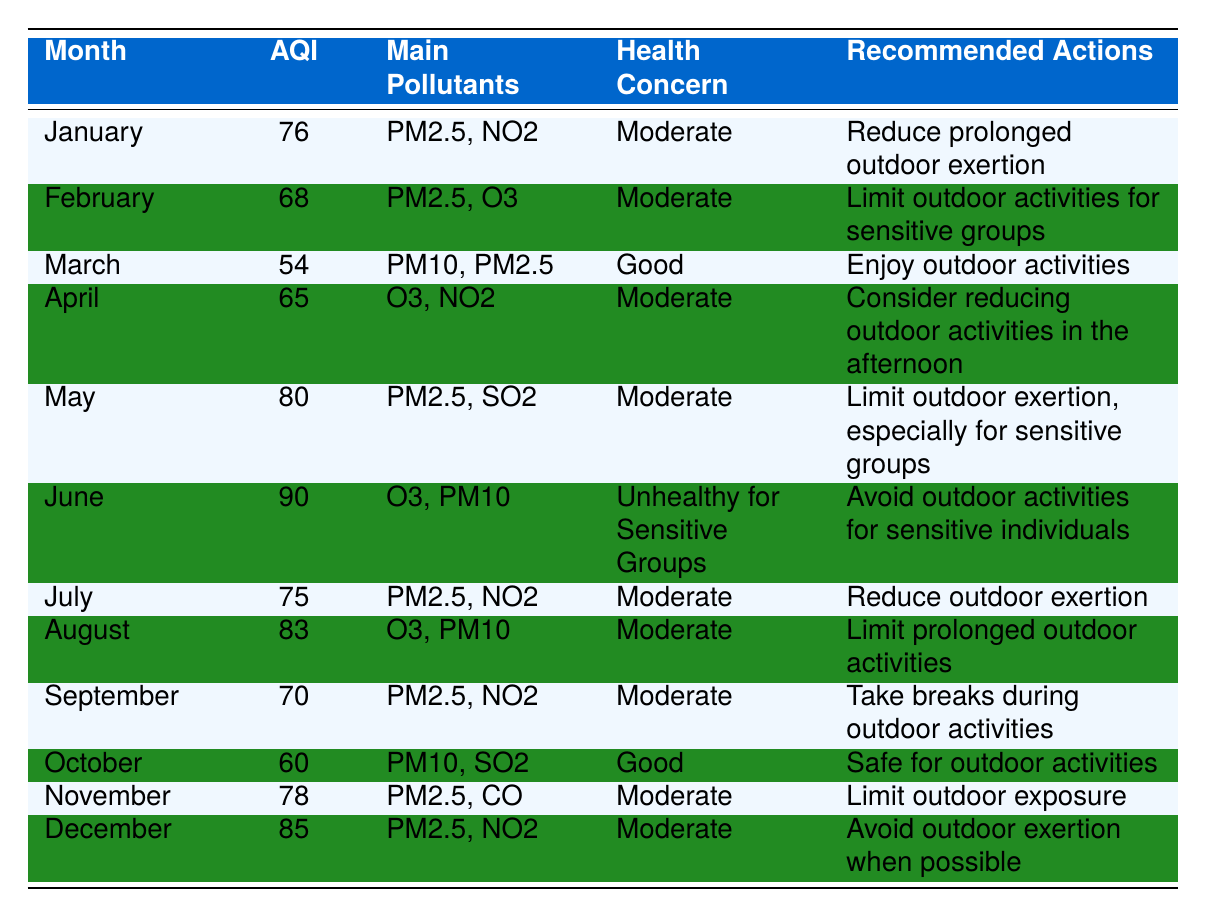What is the air quality index (AQI) for March? According to the table, the AQI listed for March is 54.
Answer: 54 Which month had the highest AQI reading in 2023? The table shows that June had the highest AQI reading of 90.
Answer: June Were there any months where the AQI was classified as Good? The table indicates that both March and October were classified as having a Good AQI.
Answer: Yes What are the main pollutants for the month of August? The table specifies that the main pollutants for August are O3 and PM10.
Answer: O3, PM10 How many months had an AQI above 75? By reviewing the AQI values in the table, only June (90), May (80), and December (85) exceed 75, resulting in a total of three months.
Answer: 3 What is the recommended action for sensitive groups in June? For June, the table advises sensitive individuals to avoid outdoor activities due to the Unhealthy for Sensitive Groups classification.
Answer: Avoid outdoor activities Which month had a lower AQI: June or November? The AQI for June is 90, while for November it is 78. Since 78 is lower than 90, November had a lower AQI.
Answer: November What is the health concern level for the month of February? The table indicates that the health concern level for February is Moderate.
Answer: Moderate Calculate the average AQI for the months classified as Good. The months classified as Good are March (54) and October (60). Their average AQI is (54 + 60) / 2 = 57.
Answer: 57 What action is recommended for outdoor activities in January? The table recommends reducing prolonged outdoor exertion in January due to the Moderate health concern level.
Answer: Reduce prolonged outdoor exertion Is there any month in 2023 that has an AQI rating of exactly 70? Based on the data in the table, September has an AQI of exactly 70.
Answer: Yes Which months have a Moderate health concern and an AQI between 75 and 80? The months of July (75) and November (78) have an AQI in the range of 75 to 80 with a Moderate health concern.
Answer: July, November 